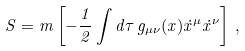Convert formula to latex. <formula><loc_0><loc_0><loc_500><loc_500>S = m \left [ - \frac { 1 } { 2 } \int d \tau \, g _ { \mu \nu } ( x ) \dot { x } ^ { \mu } \dot { x } ^ { \nu } \right ] \, ,</formula> 